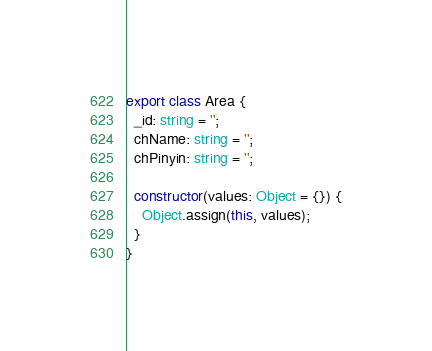Convert code to text. <code><loc_0><loc_0><loc_500><loc_500><_TypeScript_>export class Area {
  _id: string = '';
  chName: string = '';
  chPinyin: string = '';

  constructor(values: Object = {}) {
    Object.assign(this, values);
  }
}</code> 